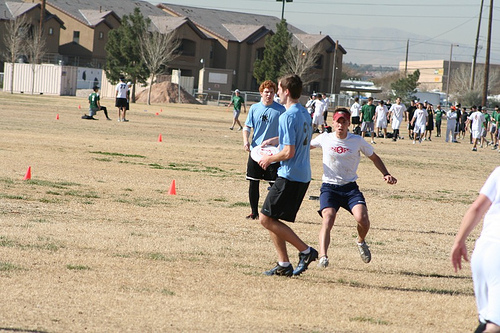<image>What job do the men in the picture do? I am not sure about the job the men in the picture do. It can include frisbee player, referee, athlete, or professional flying disc players. What job do the men in the picture do? It is ambiguous what job the men in the picture do. They can be frisbee players or referees. 